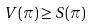<formula> <loc_0><loc_0><loc_500><loc_500>V ( \pi ) \geq S ( \pi )</formula> 